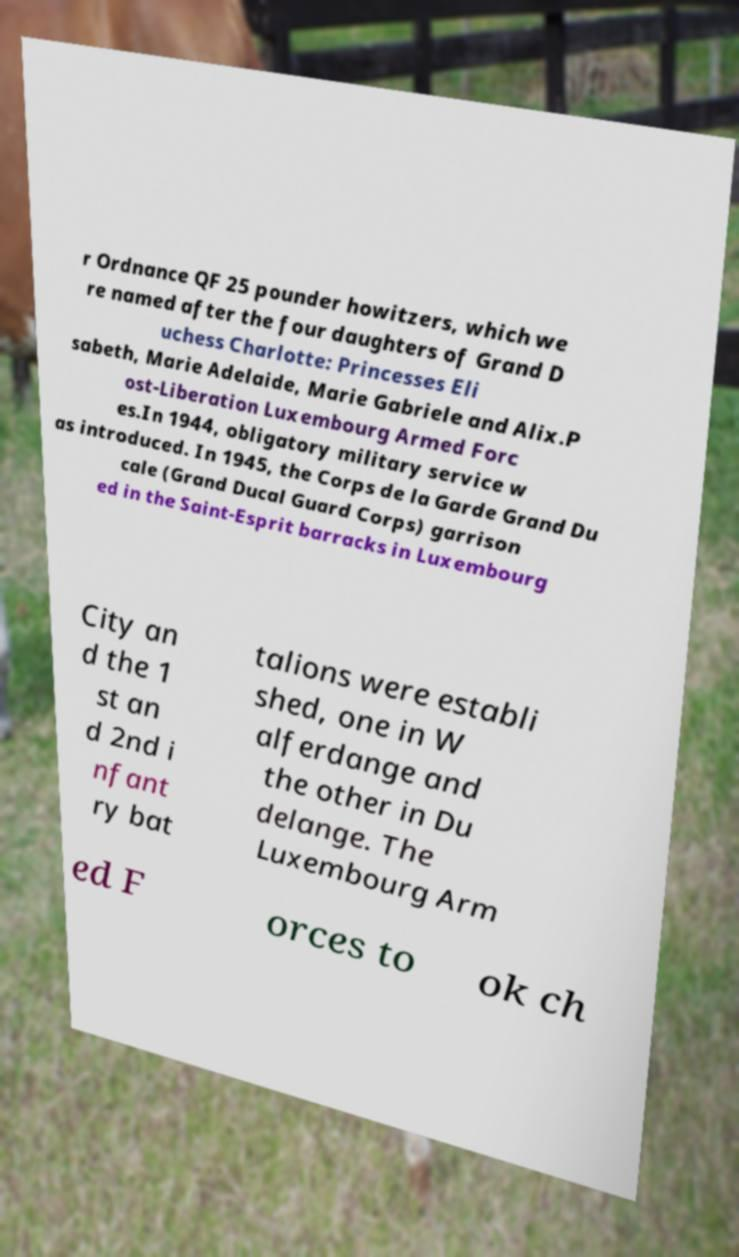Can you read and provide the text displayed in the image?This photo seems to have some interesting text. Can you extract and type it out for me? r Ordnance QF 25 pounder howitzers, which we re named after the four daughters of Grand D uchess Charlotte: Princesses Eli sabeth, Marie Adelaide, Marie Gabriele and Alix.P ost-Liberation Luxembourg Armed Forc es.In 1944, obligatory military service w as introduced. In 1945, the Corps de la Garde Grand Du cale (Grand Ducal Guard Corps) garrison ed in the Saint-Esprit barracks in Luxembourg City an d the 1 st an d 2nd i nfant ry bat talions were establi shed, one in W alferdange and the other in Du delange. The Luxembourg Arm ed F orces to ok ch 